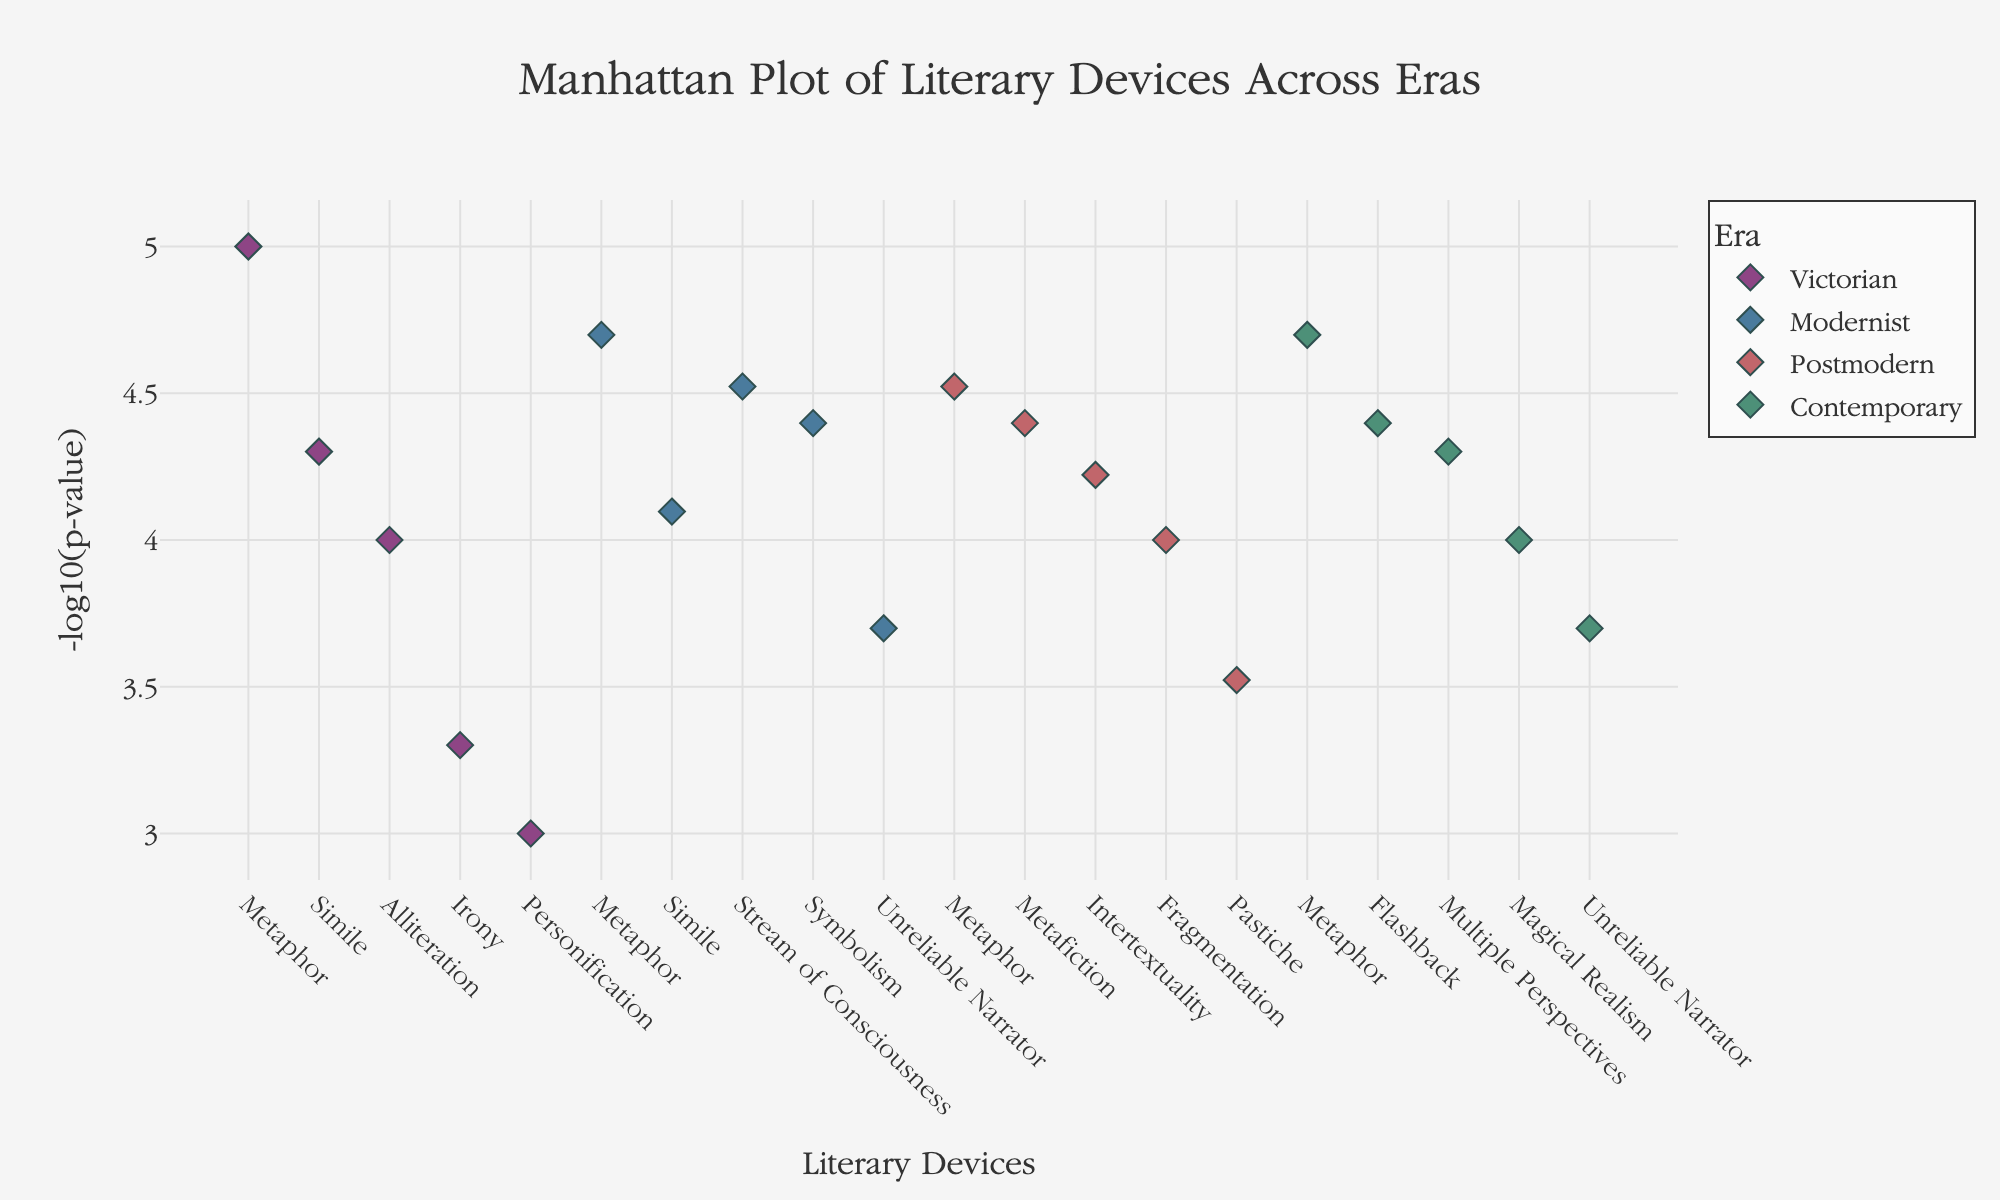What's the title of the figure? The title of the figure is typically displayed prominently at the top of the plot. Here, it is "Manhattan Plot of Literary Devices Across Eras".
Answer: Manhattan Plot of Literary Devices Across Eras What is represented on the y-axis? The y-axis displays the -log10(p-value), which is a transformed version of the p-value to allow for easier comparison of statistical significance.
Answer: -log10(p-value) How many literary devices are shown for the Victorian era? Each era is represented by a different color with markers labeled by literary devices. For the Victorian era (color-coded), there are markers for Metaphor, Simile, Alliteration, Irony, and Personification - totaling five literary devices.
Answer: Five Which era's literary device has the highest -log10(p-value) and what is it? By examining the y-axis values and the hover information of each era, the highest -log10(p-value) appears under the Victorian era for Metaphor.
Answer: Victorian, Metaphor What is the color code for Modernist era data points? The Modernist era is represented by a distinct color. By examining the markers of Modernist data points, the color used is a shade of blue.
Answer: Blue What is the sum of the -log10(p-value) for the Victorian era literary devices? Victorian era includes Metaphor (5), Simile (4.3), Alliteration (4), Irony (3.3), and Personification (3). Summing these values gives 5 + 4.3 + 4 + 3.3 + 3 = 19.6.
Answer: 19.6 Which literary device among the eras has the lowest -log10(p-value) and what is it? By examining the y-axis values, the lowest -log10(p-value) corresponds to the highest p-value. The Postmodern era's Pastiche has the value closest to the x-axis at -log10(0.0003).
Answer: Postmodern, Pastiche Which era has the most literary devices displayed? By counting the distinct markers in each colored segment of the plot, the Postmodern and Contemporary eras both have five distinct devices each displayed.
Answer: Postmodern and Contemporary Compare the -log10(p-value) for Metaphor across all eras, and identify the era with the second highest value. By examining the positions of Metaphor markers across eras, Victorian's Metaphor (highest), Contemporary's Metaphor (second highest), Modernist's Metaphor, and Postmodern's Metaphor. The second highest -log10(p-value) for Metaphor is in the Contemporary era.
Answer: Contemporary What is the average -log10(p-value) of the top three literary devices in the Modernist era? Identifying the top three -log10(p-values) in the Modernist era: Metaphor (4.7), Stream of Consciousness (4.5), and Symbolism (4.5). Average = (4.7 + 4.5 + 4.5) / 3 = 4.5667.
Answer: 4.5667 